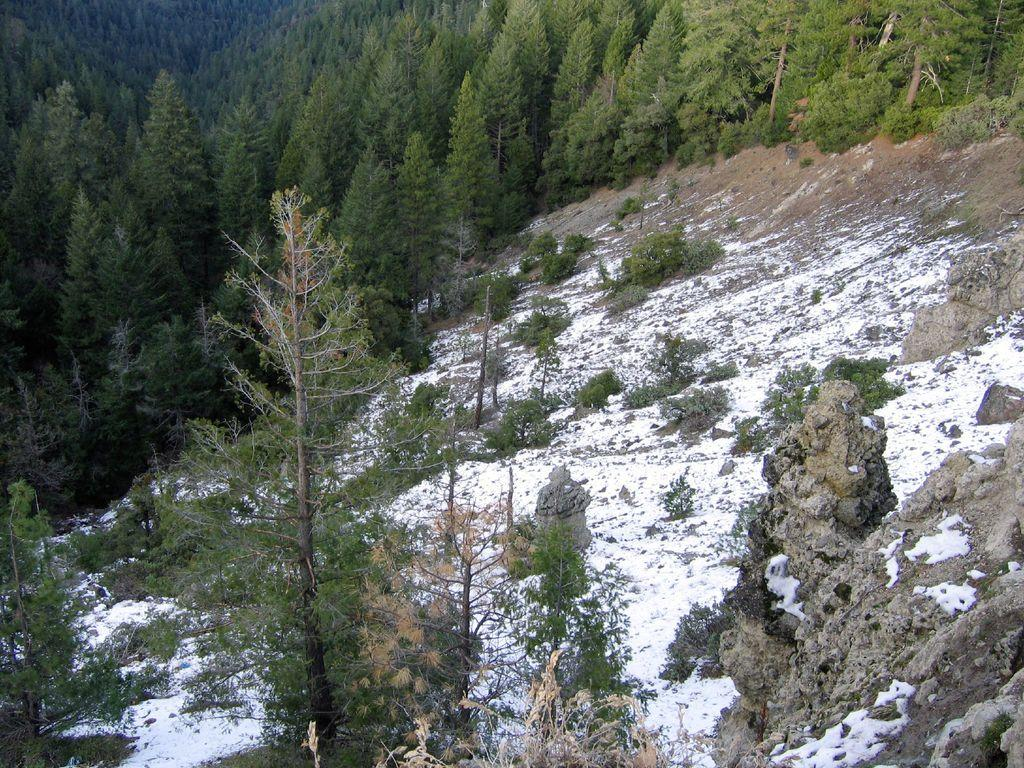What type of natural elements can be seen in the image? There are rocks, snow, and trees in the image. Can you describe the terrain in the image? The terrain in the image is characterized by rocks and snow. What type of vegetation is present in the image? There are trees in the image. Can you see a spade being used to dig through the snow in the image? There is no spade present in the image, and therefore no such activity can be observed. 